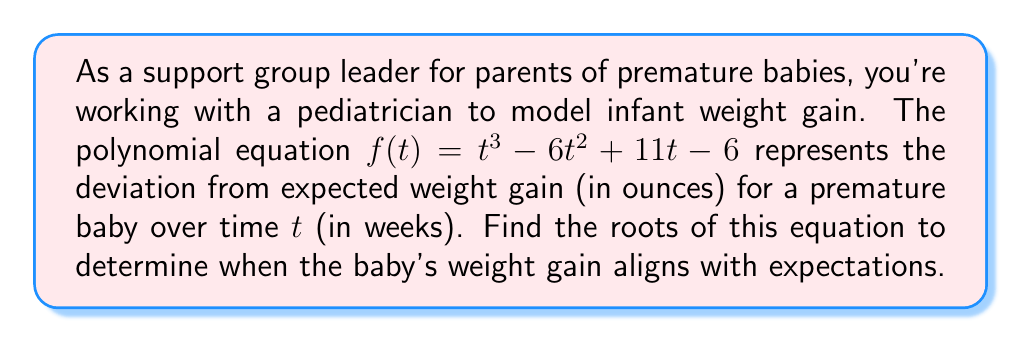Give your solution to this math problem. To find the roots of the polynomial equation $f(t) = t^3 - 6t^2 + 11t - 6$, we need to solve $f(t) = 0$. Let's approach this step-by-step:

1) First, let's check if there are any rational roots using the rational root theorem. The possible rational roots are the factors of the constant term: $\pm 1, \pm 2, \pm 3, \pm 6$.

2) Testing these values, we find that $t = 1$ is a root. So $(t - 1)$ is a factor of the polynomial.

3) We can use polynomial long division to find the other factor:

   $t^3 - 6t^2 + 11t - 6 = (t - 1)(t^2 - 5t + 6)$

4) Now we need to solve $t^2 - 5t + 6 = 0$. This is a quadratic equation.

5) We can solve this using the quadratic formula: $t = \frac{-b \pm \sqrt{b^2 - 4ac}}{2a}$

   Where $a = 1$, $b = -5$, and $c = 6$

6) Substituting into the formula:

   $t = \frac{5 \pm \sqrt{25 - 24}}{2} = \frac{5 \pm 1}{2}$

7) This gives us two more roots: $t = 3$ and $t = 2$

Therefore, the roots of the equation are $t = 1$, $t = 2$, and $t = 3$.
Answer: The roots of the equation are 1, 2, and 3 weeks. 